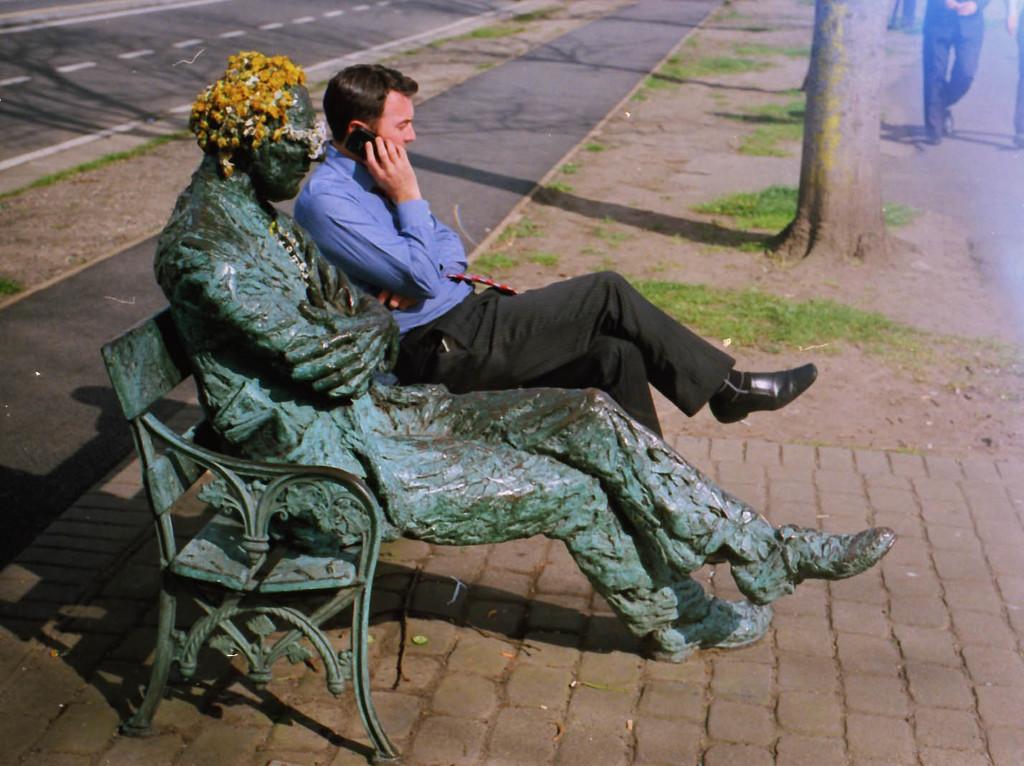Could you give a brief overview of what you see in this image? In this picture we can see a statue on the iron bench. Beside there is a man sitting and wearing a blue color shirt and talking on the phone. Behind there is a tree trunk and road. 